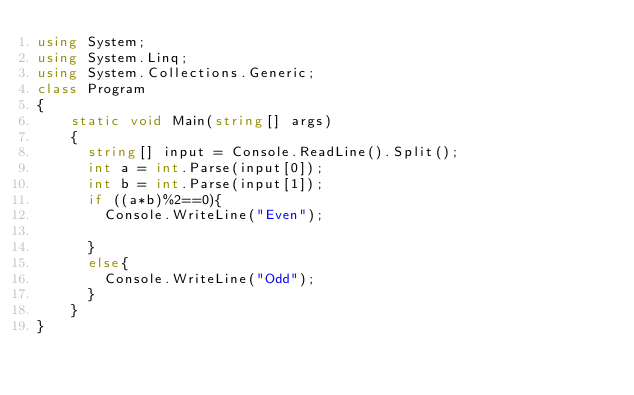<code> <loc_0><loc_0><loc_500><loc_500><_C#_>using System;
using System.Linq;
using System.Collections.Generic;
class Program
{
    static void Main(string[] args)
    {
      string[] input = Console.ReadLine().Split();
      int a = int.Parse(input[0]);
      int b = int.Parse(input[1]);
      if ((a*b)%2==0){
        Console.WriteLine("Even");
        
      }
      else{
        Console.WriteLine("Odd");
      }
    }
}
</code> 